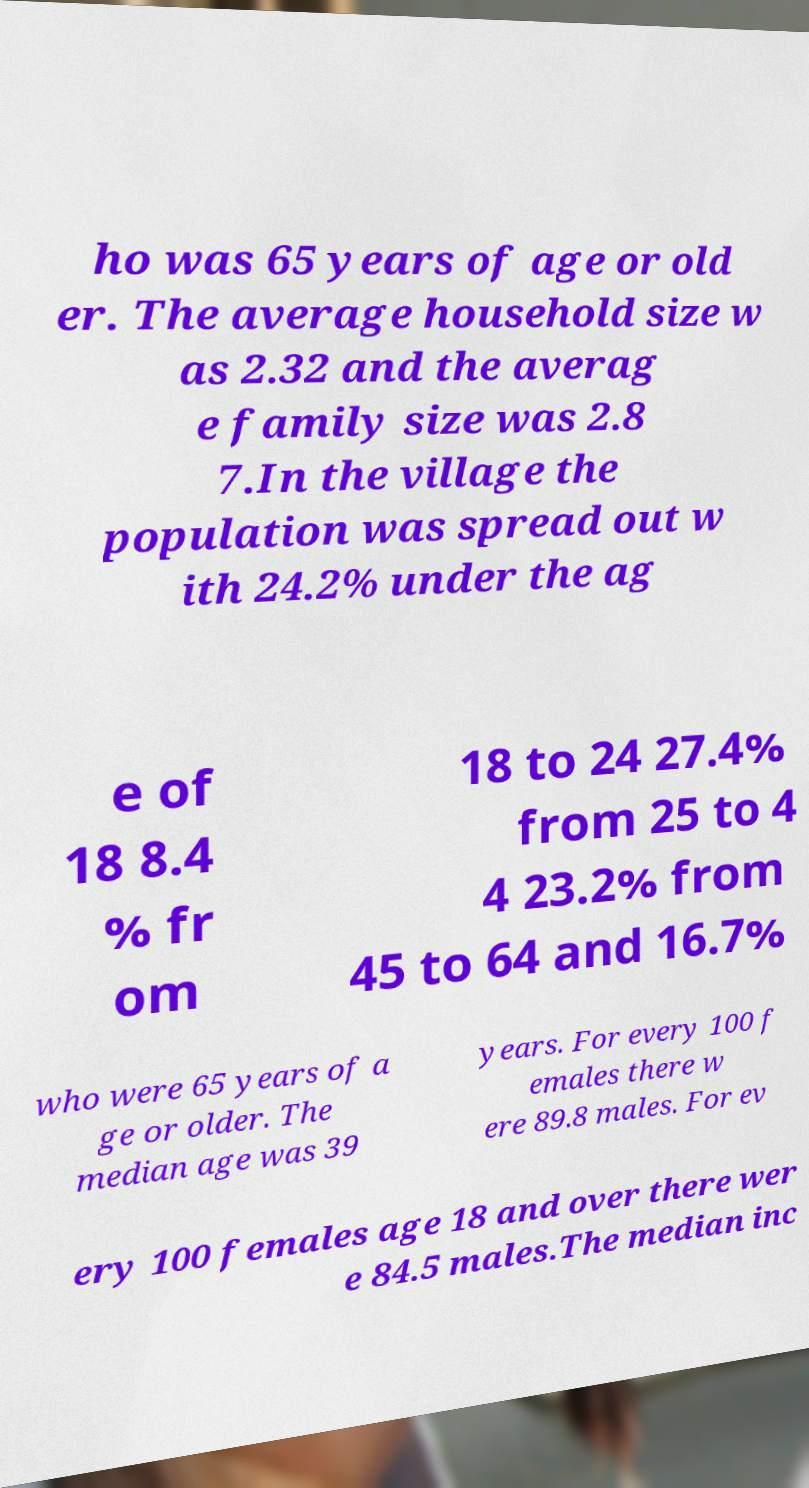For documentation purposes, I need the text within this image transcribed. Could you provide that? ho was 65 years of age or old er. The average household size w as 2.32 and the averag e family size was 2.8 7.In the village the population was spread out w ith 24.2% under the ag e of 18 8.4 % fr om 18 to 24 27.4% from 25 to 4 4 23.2% from 45 to 64 and 16.7% who were 65 years of a ge or older. The median age was 39 years. For every 100 f emales there w ere 89.8 males. For ev ery 100 females age 18 and over there wer e 84.5 males.The median inc 